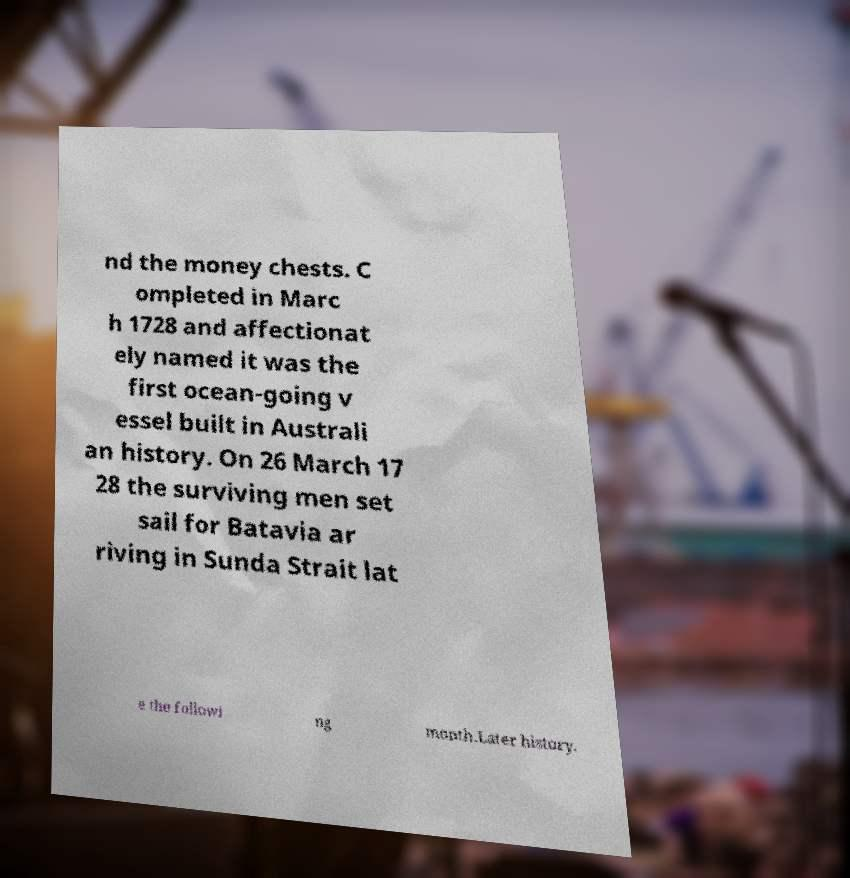Please read and relay the text visible in this image. What does it say? nd the money chests. C ompleted in Marc h 1728 and affectionat ely named it was the first ocean-going v essel built in Australi an history. On 26 March 17 28 the surviving men set sail for Batavia ar riving in Sunda Strait lat e the followi ng month.Later history. 